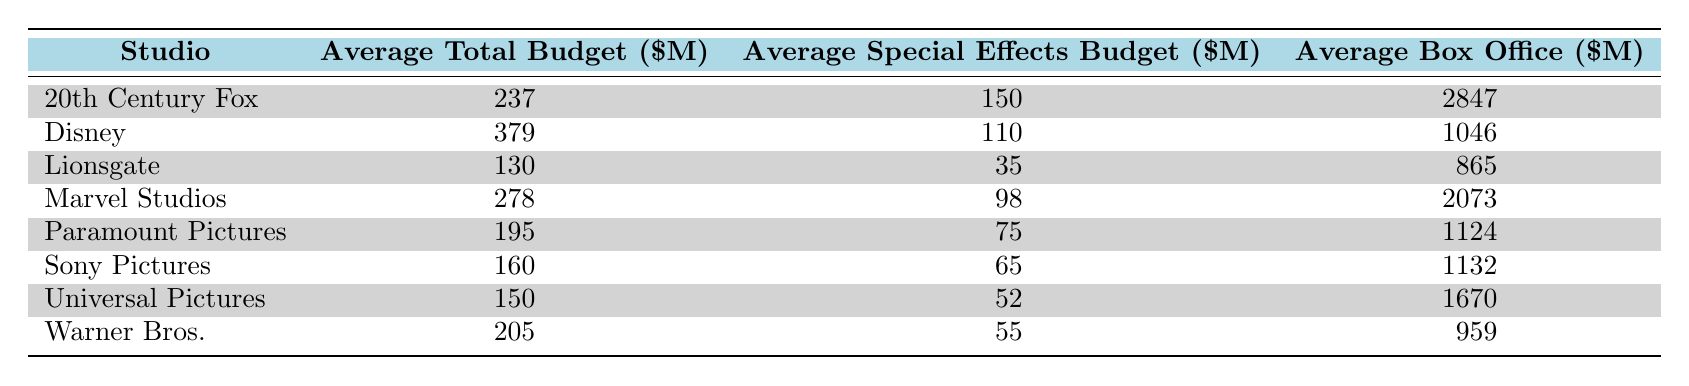What's the average total budget for movies produced by Disney? The table shows that Disney has an average total budget of 379 million dollars.
Answer: 379 Which studio has the highest average box office? Based on the table, 20th Century Fox has the highest average box office revenue of 2847 million dollars.
Answer: 2847 How much more, on average, does Marvel Studios spend on special effects compared to Warner Bros.? Marvel Studios spends an average of 98 million dollars on special effects, while Warner Bros. spends 55 million dollars. The difference is 98 - 55 = 43 million dollars.
Answer: 43 Is the average special effects budget for Sony Pictures greater than that for Lionsgate? According to the table, Sony Pictures has an average special effects budget of 65 million dollars, while Lionsgate has 35 million dollars. Since 65 is greater than 35, the statement is true.
Answer: Yes What’s the total average budget for all the studios combined in the table? To calculate the total average budget, we add the average total budgets of all studios: 237 + 379 + 130 + 278 + 195 + 160 + 150 + 205 = 1934 million dollars. Then, we divide by the number of studios (8): 1934 / 8 = 241.75 million dollars.
Answer: 241.75 What is the average box office for Universal Pictures compared to the industry average of the studios listed? Universal Pictures has an average box office of 1670 million dollars. The combined average box office of all studios from the table is (2847 + 1046 + 865 + 2073 + 1124 + 1132 + 959) / 7 = 1581.14 million dollars. Since 1670 is greater than 1581.14, Universal Pictures exceeds the average.
Answer: Yes What is the difference in average total budgets between Disney and Paramount Pictures? Disney has an average total budget of 379 million dollars while Paramount Pictures has 195 million dollars. The difference is 379 - 195 = 184 million dollars.
Answer: 184 Is there a studio that has a lower average special effects budget than 40 million dollars? The table shows that Lionsgate has an average special effects budget of 35 million dollars, which is lower than 40 million dollars.
Answer: Yes 